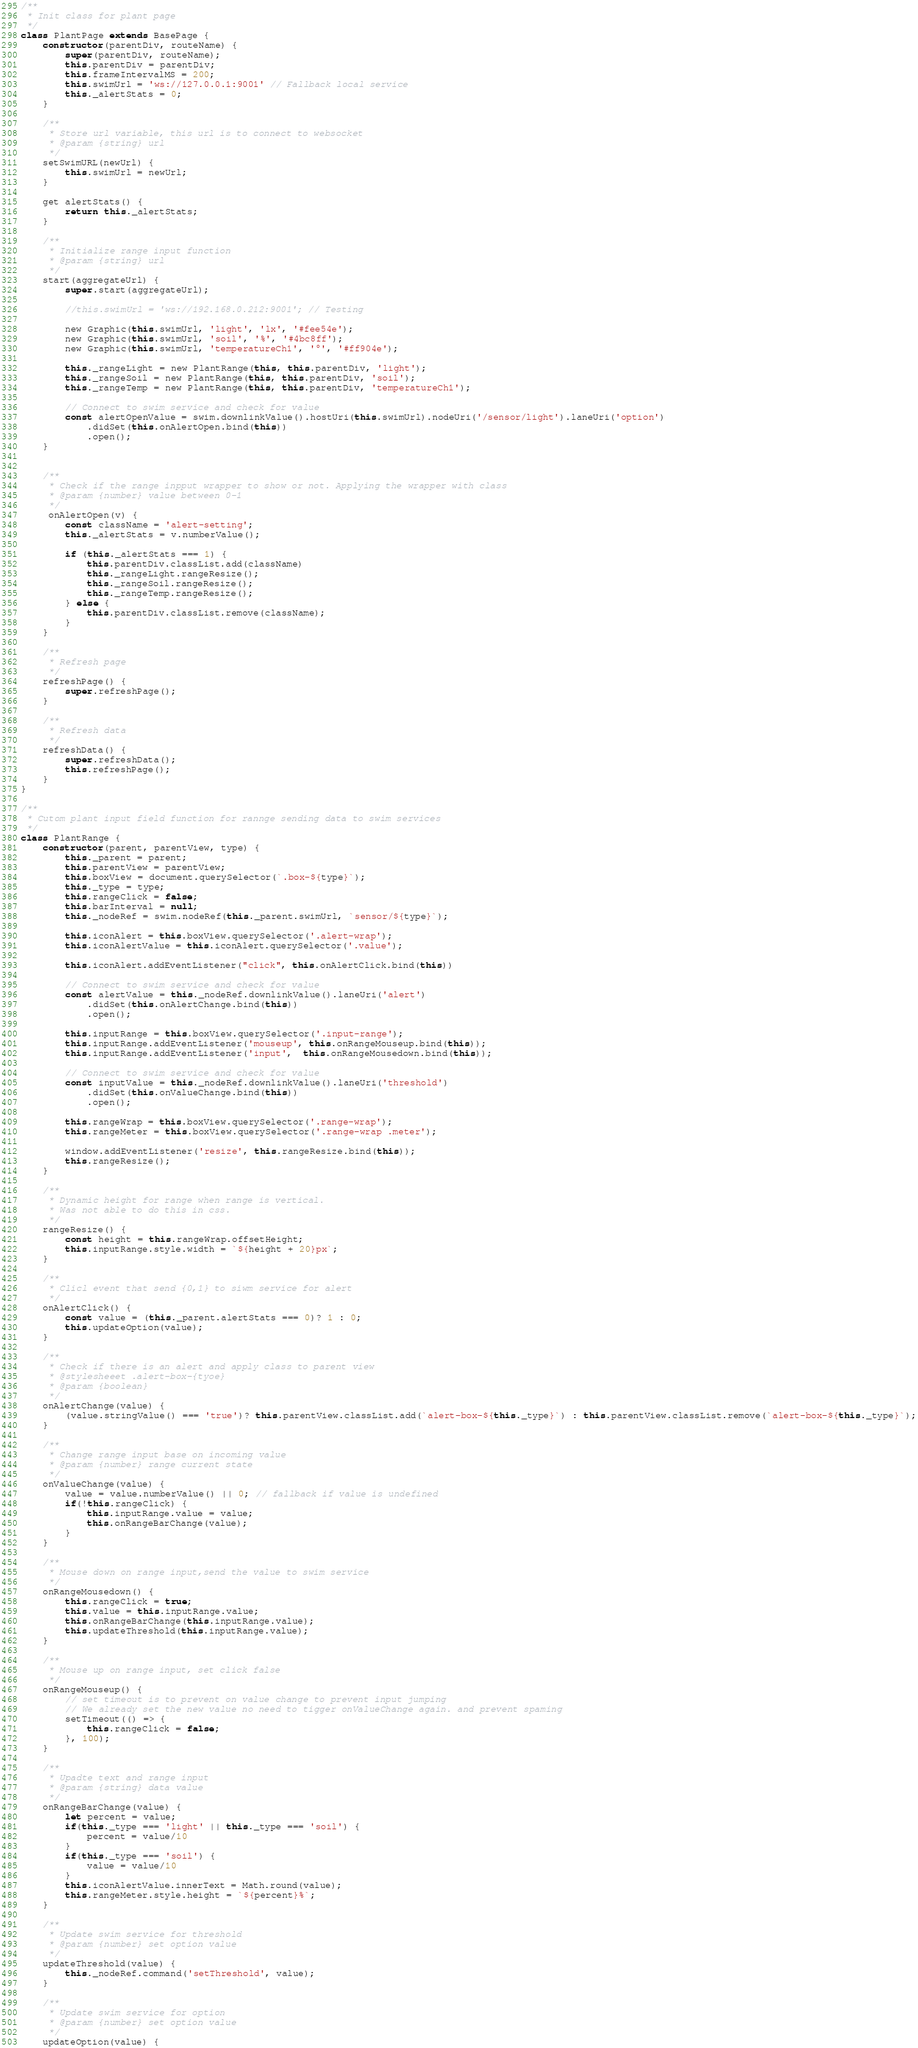Convert code to text. <code><loc_0><loc_0><loc_500><loc_500><_JavaScript_>/**
 * Init class for plant page
 */
class PlantPage extends BasePage {
    constructor(parentDiv, routeName) {
        super(parentDiv, routeName);
        this.parentDiv = parentDiv;
        this.frameIntervalMS = 200;
        this.swimUrl = 'ws://127.0.0.1:9001' // Fallback local service
        this._alertStats = 0;
    }

    /**
     * Store url variable, this url is to connect to websocket
     * @param {string} url
     */
    setSwimURL(newUrl) {
        this.swimUrl = newUrl;
    }

    get alertStats() {
        return this._alertStats;
    }

    /**
     * Initialize range input function
     * @param {string} url
     */
    start(aggregateUrl) {
        super.start(aggregateUrl);

        //this.swimUrl = 'ws://192.168.0.212:9001'; // Testing

        new Graphic(this.swimUrl, 'light', 'lx', '#fee54e');
        new Graphic(this.swimUrl, 'soil', '%', '#4bc8ff');
        new Graphic(this.swimUrl, 'temperatureCh1', '°', '#ff904e');

        this._rangeLight = new PlantRange(this, this.parentDiv, 'light');
        this._rangeSoil = new PlantRange(this, this.parentDiv, 'soil');
        this._rangeTemp = new PlantRange(this, this.parentDiv, 'temperatureCh1');

        // Connect to swim service and check for value
        const alertOpenValue = swim.downlinkValue().hostUri(this.swimUrl).nodeUri('/sensor/light').laneUri('option')
            .didSet(this.onAlertOpen.bind(this))
            .open();
    }


    /**
     * Check if the range inpput wrapper to show or not. Applying the wrapper with class
     * @param {number} value between 0-1
     */
     onAlertOpen(v) {
        const className = 'alert-setting';
        this._alertStats = v.numberValue();

        if (this._alertStats === 1) {
            this.parentDiv.classList.add(className)
            this._rangeLight.rangeResize();
            this._rangeSoil.rangeResize();
            this._rangeTemp.rangeResize();
        } else {
            this.parentDiv.classList.remove(className);
        }
    }

    /**
     * Refresh page
     */
    refreshPage() {
        super.refreshPage();
    }

    /**
     * Refresh data
     */
    refreshData() {
        super.refreshData();
        this.refreshPage();
    }
}

/**
 * Cutom plant input field function for rannge sending data to swim services
 */
class PlantRange {
    constructor(parent, parentView, type) {
        this._parent = parent;
        this.parentView = parentView;
        this.boxView = document.querySelector(`.box-${type}`);
        this._type = type;
        this.rangeClick = false;
        this.barInterval = null;
        this._nodeRef = swim.nodeRef(this._parent.swimUrl, `sensor/${type}`);

        this.iconAlert = this.boxView.querySelector('.alert-wrap');
        this.iconAlertValue = this.iconAlert.querySelector('.value');

        this.iconAlert.addEventListener("click", this.onAlertClick.bind(this))

        // Connect to swim service and check for value
        const alertValue = this._nodeRef.downlinkValue().laneUri('alert')
            .didSet(this.onAlertChange.bind(this))
            .open();

        this.inputRange = this.boxView.querySelector('.input-range');
        this.inputRange.addEventListener('mouseup', this.onRangeMouseup.bind(this));
        this.inputRange.addEventListener('input',  this.onRangeMousedown.bind(this));

        // Connect to swim service and check for value
        const inputValue = this._nodeRef.downlinkValue().laneUri('threshold')
            .didSet(this.onValueChange.bind(this))
            .open();

        this.rangeWrap = this.boxView.querySelector('.range-wrap');
        this.rangeMeter = this.boxView.querySelector('.range-wrap .meter');

        window.addEventListener('resize', this.rangeResize.bind(this));
        this.rangeResize();
    }

    /**
     * Dynamic height for range when range is vertical.
     * Was not able to do this in css.
     */
    rangeResize() {
        const height = this.rangeWrap.offsetHeight;
        this.inputRange.style.width = `${height + 20}px`;
    }

    /**
     * Clicl event that send {0,1} to siwm service for alert
     */
    onAlertClick() {
        const value = (this._parent.alertStats === 0)? 1 : 0;
        this.updateOption(value);
    }

    /**
     * Check if there is an alert and apply class to parent view
     * @stylesheeet .alert-box-{tyoe}
     * @param {boolean}
     */
    onAlertChange(value) {
        (value.stringValue() === 'true')? this.parentView.classList.add(`alert-box-${this._type}`) : this.parentView.classList.remove(`alert-box-${this._type}`);
    }

    /**
     * Change range input base on incoming value
     * @param {number} range current state
     */
    onValueChange(value) {
        value = value.numberValue() || 0; // fallback if value is undefined
        if(!this.rangeClick) {
            this.inputRange.value = value;
            this.onRangeBarChange(value);
        }
    }

    /**
     * Mouse down on range input,send the value to swim service
     */
    onRangeMousedown() {
        this.rangeClick = true;
        this.value = this.inputRange.value;
        this.onRangeBarChange(this.inputRange.value);
        this.updateThreshold(this.inputRange.value);
    }

    /**
     * Mouse up on range input, set click false
     */
    onRangeMouseup() {
        // set timeout is to prevent on value change to prevent input jumping
        // We already set the new value no need to tigger onValueChange again. and prevent spaming
        setTimeout(() => {
            this.rangeClick = false;
        }, 100);
    }

    /**
     * Upadte text and range input
     * @param {string} data value
     */
    onRangeBarChange(value) {
        let percent = value;
        if(this._type === 'light' || this._type === 'soil') {
            percent = value/10
        }
        if(this._type === 'soil') {
            value = value/10
        }
        this.iconAlertValue.innerText = Math.round(value);
        this.rangeMeter.style.height = `${percent}%`;
    }

    /**
     * Update swim service for threshold
     * @param {number} set option value
     */
    updateThreshold(value) {
        this._nodeRef.command('setThreshold', value);
    }

    /**
     * Update swim service for option
     * @param {number} set option value
     */
    updateOption(value) {</code> 